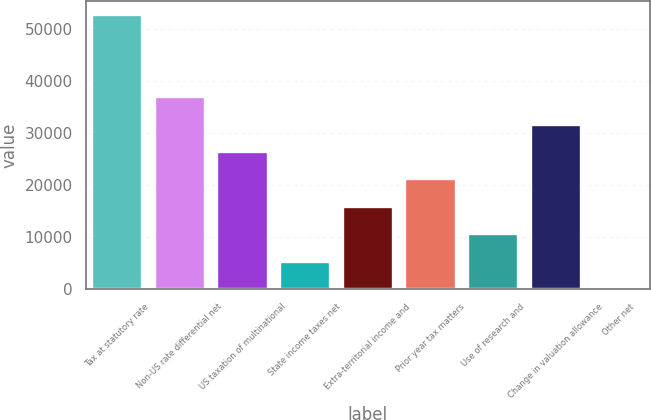Convert chart to OTSL. <chart><loc_0><loc_0><loc_500><loc_500><bar_chart><fcel>Tax at statutory rate<fcel>Non-US rate differential net<fcel>US taxation of multinational<fcel>State income taxes net<fcel>Extra-territorial income and<fcel>Prior year tax matters<fcel>Use of research and<fcel>Change in valuation allowance<fcel>Other net<nl><fcel>52758<fcel>36942.9<fcel>26399.5<fcel>5312.7<fcel>15856.1<fcel>21127.8<fcel>10584.4<fcel>31671.2<fcel>41<nl></chart> 